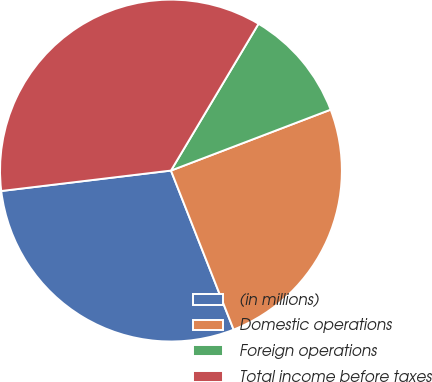Convert chart to OTSL. <chart><loc_0><loc_0><loc_500><loc_500><pie_chart><fcel>(in millions)<fcel>Domestic operations<fcel>Foreign operations<fcel>Total income before taxes<nl><fcel>29.07%<fcel>24.83%<fcel>10.64%<fcel>35.47%<nl></chart> 